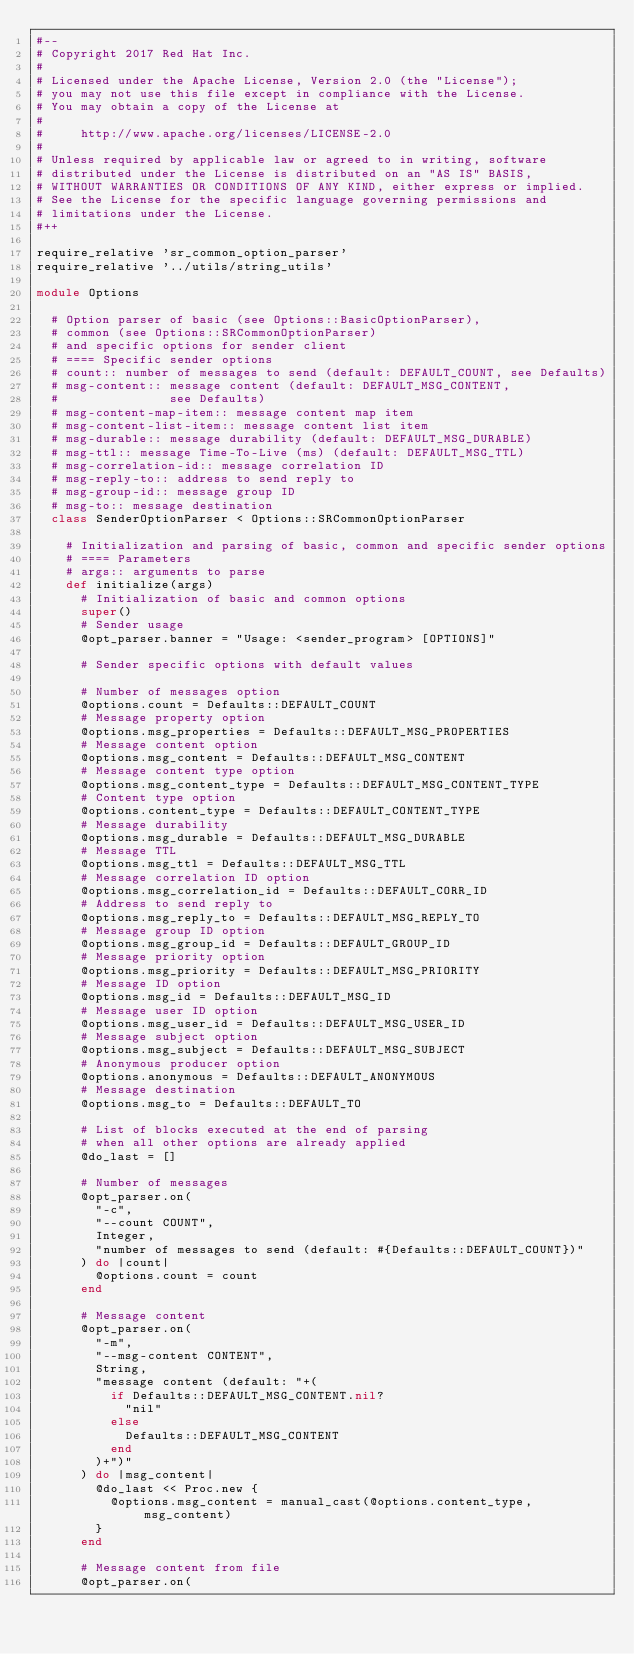<code> <loc_0><loc_0><loc_500><loc_500><_Ruby_>#--
# Copyright 2017 Red Hat Inc.
#
# Licensed under the Apache License, Version 2.0 (the "License");
# you may not use this file except in compliance with the License.
# You may obtain a copy of the License at
#
#     http://www.apache.org/licenses/LICENSE-2.0
#
# Unless required by applicable law or agreed to in writing, software
# distributed under the License is distributed on an "AS IS" BASIS,
# WITHOUT WARRANTIES OR CONDITIONS OF ANY KIND, either express or implied.
# See the License for the specific language governing permissions and
# limitations under the License.
#++

require_relative 'sr_common_option_parser'
require_relative '../utils/string_utils'

module Options

  # Option parser of basic (see Options::BasicOptionParser),
  # common (see Options::SRCommonOptionParser)
  # and specific options for sender client
  # ==== Specific sender options
  # count:: number of messages to send (default: DEFAULT_COUNT, see Defaults)
  # msg-content:: message content (default: DEFAULT_MSG_CONTENT,
  #               see Defaults)
  # msg-content-map-item:: message content map item
  # msg-content-list-item:: message content list item
  # msg-durable:: message durability (default: DEFAULT_MSG_DURABLE)
  # msg-ttl:: message Time-To-Live (ms) (default: DEFAULT_MSG_TTL)
  # msg-correlation-id:: message correlation ID
  # msg-reply-to:: address to send reply to
  # msg-group-id:: message group ID
  # msg-to:: message destination
  class SenderOptionParser < Options::SRCommonOptionParser

    # Initialization and parsing of basic, common and specific sender options
    # ==== Parameters
    # args:: arguments to parse
    def initialize(args)
      # Initialization of basic and common options
      super()
      # Sender usage
      @opt_parser.banner = "Usage: <sender_program> [OPTIONS]"

      # Sender specific options with default values

      # Number of messages option
      @options.count = Defaults::DEFAULT_COUNT
      # Message property option
      @options.msg_properties = Defaults::DEFAULT_MSG_PROPERTIES
      # Message content option
      @options.msg_content = Defaults::DEFAULT_MSG_CONTENT
      # Message content type option
      @options.msg_content_type = Defaults::DEFAULT_MSG_CONTENT_TYPE
      # Content type option
      @options.content_type = Defaults::DEFAULT_CONTENT_TYPE
      # Message durability
      @options.msg_durable = Defaults::DEFAULT_MSG_DURABLE
      # Message TTL
      @options.msg_ttl = Defaults::DEFAULT_MSG_TTL
      # Message correlation ID option
      @options.msg_correlation_id = Defaults::DEFAULT_CORR_ID
      # Address to send reply to
      @options.msg_reply_to = Defaults::DEFAULT_MSG_REPLY_TO
      # Message group ID option
      @options.msg_group_id = Defaults::DEFAULT_GROUP_ID
      # Message priority option
      @options.msg_priority = Defaults::DEFAULT_MSG_PRIORITY
      # Message ID option
      @options.msg_id = Defaults::DEFAULT_MSG_ID
      # Message user ID option
      @options.msg_user_id = Defaults::DEFAULT_MSG_USER_ID
      # Message subject option
      @options.msg_subject = Defaults::DEFAULT_MSG_SUBJECT
      # Anonymous producer option
      @options.anonymous = Defaults::DEFAULT_ANONYMOUS
      # Message destination
      @options.msg_to = Defaults::DEFAULT_TO

      # List of blocks executed at the end of parsing
      # when all other options are already applied
      @do_last = []

      # Number of messages
      @opt_parser.on(
        "-c",
        "--count COUNT",
        Integer,
        "number of messages to send (default: #{Defaults::DEFAULT_COUNT})"
      ) do |count|
        @options.count = count
      end

      # Message content
      @opt_parser.on(
        "-m",
        "--msg-content CONTENT",
        String,
        "message content (default: "+(
          if Defaults::DEFAULT_MSG_CONTENT.nil?
            "nil"
          else
            Defaults::DEFAULT_MSG_CONTENT
          end
        )+")"
      ) do |msg_content|
        @do_last << Proc.new {
          @options.msg_content = manual_cast(@options.content_type, msg_content)
        }
      end

      # Message content from file
      @opt_parser.on(</code> 